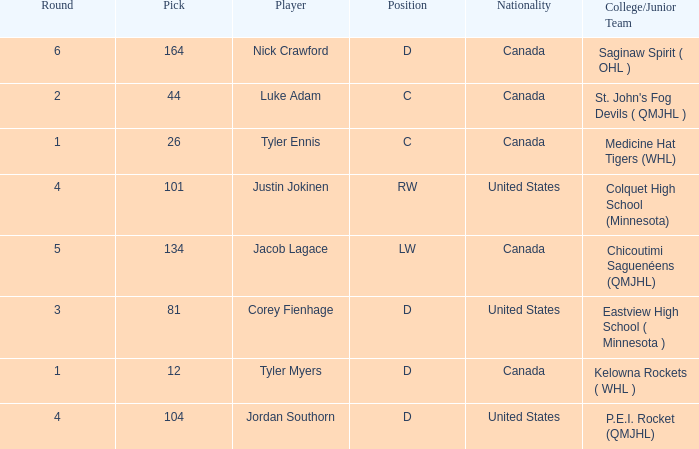What is the nationality of player corey fienhage, who has a pick less than 104? United States. 